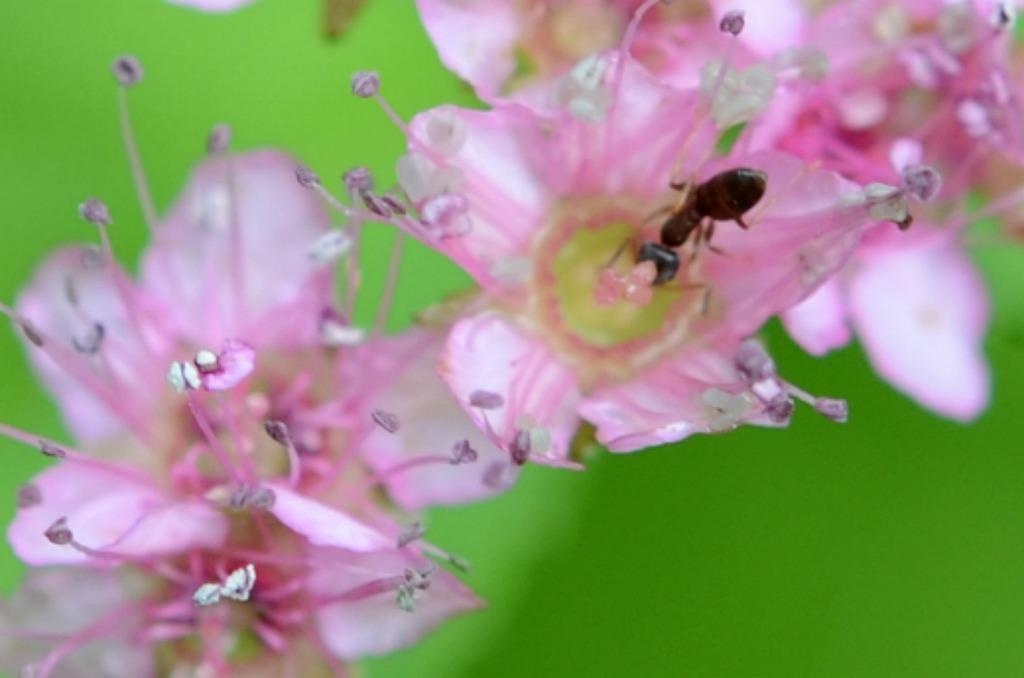What type of flower is in the image? There is a pink flower in the image. Is there anything on the flower? Yes, there is a black ant on the flower. What can be seen in the background of the image? The background of the image is green and blurred. Where is the machine that hates the flower located in the image? There is no machine present in the image, and the flower is not being hated on. 